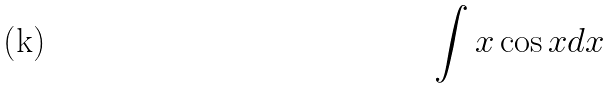<formula> <loc_0><loc_0><loc_500><loc_500>\int x \cos x d x</formula> 